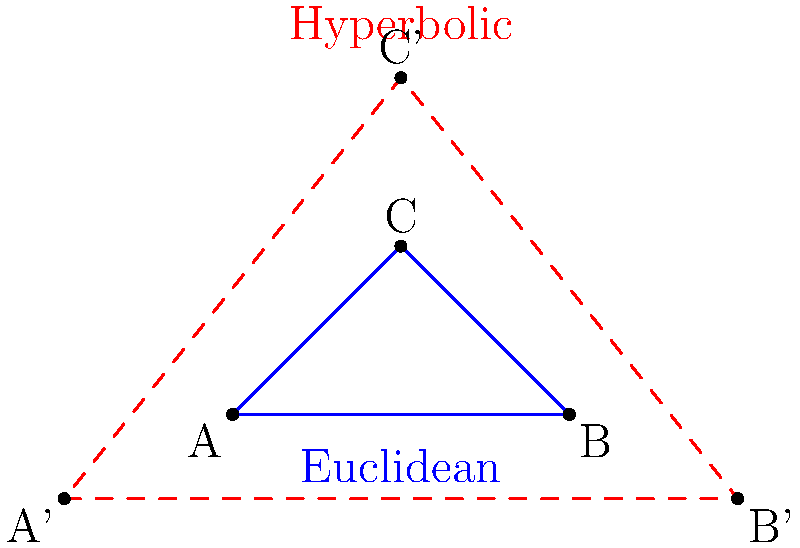In a football game between the San Francisco 49ers and their rivals, the coach uses a diagram to explain defensive formations. He draws two triangles: a blue Euclidean triangle and a red hyperbolic triangle. If the sum of angles in the Euclidean triangle is 180°, what is the sum of angles in the hyperbolic triangle? To understand the difference between Euclidean and hyperbolic triangles, let's break it down step-by-step:

1. Euclidean Triangle:
   - In Euclidean geometry, the sum of angles in a triangle is always 180°.
   - This is represented by the blue triangle in the diagram.

2. Hyperbolic Triangle:
   - In hyperbolic geometry, the rules are different.
   - The sum of angles in a hyperbolic triangle is always less than 180°.

3. Key Difference:
   - The difference arises from the curvature of space in hyperbolic geometry.
   - Imagine the surface of a football: it has negative curvature, similar to hyperbolic space.

4. Angle Deficit:
   - In hyperbolic geometry, there's a concept called "angle deficit."
   - The angle deficit is the difference between 180° and the sum of angles in a hyperbolic triangle.
   - This deficit is proportional to the area of the triangle.

5. Variability:
   - Unlike Euclidean triangles, the sum of angles in a hyperbolic triangle can vary.
   - It depends on the size of the triangle in hyperbolic space.
   - Larger hyperbolic triangles have a smaller sum of angles.

6. Range:
   - The sum of angles in a hyperbolic triangle can be any value between 0° and 180°.
   - It approaches 180° for very small triangles but never reaches it.

Therefore, while we can't give an exact value without more information about the specific hyperbolic triangle, we can confidently say that the sum of its angles will be less than 180°.
Answer: Less than 180° 